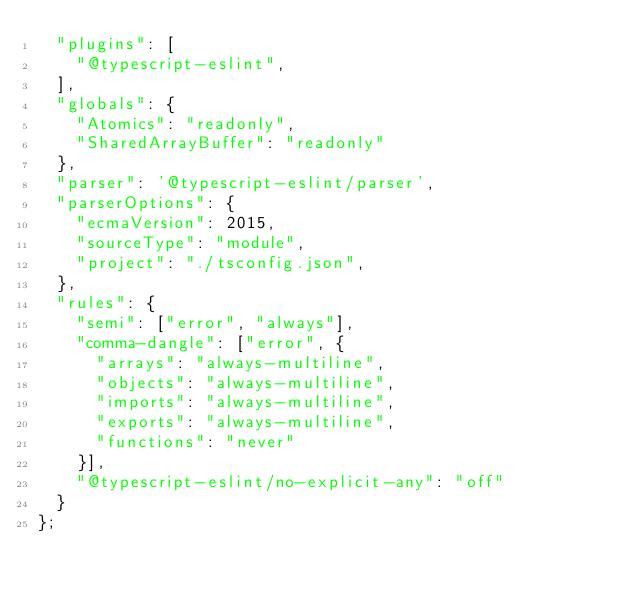Convert code to text. <code><loc_0><loc_0><loc_500><loc_500><_JavaScript_>  "plugins": [
    "@typescript-eslint",
  ],
  "globals": {
    "Atomics": "readonly",
    "SharedArrayBuffer": "readonly"
  },
  "parser": '@typescript-eslint/parser',
  "parserOptions": {
    "ecmaVersion": 2015,
    "sourceType": "module",
    "project": "./tsconfig.json",
  },
  "rules": {
    "semi": ["error", "always"],
    "comma-dangle": ["error", {
      "arrays": "always-multiline",
      "objects": "always-multiline",
      "imports": "always-multiline",
      "exports": "always-multiline",
      "functions": "never"
    }],
    "@typescript-eslint/no-explicit-any": "off"
  }
};</code> 